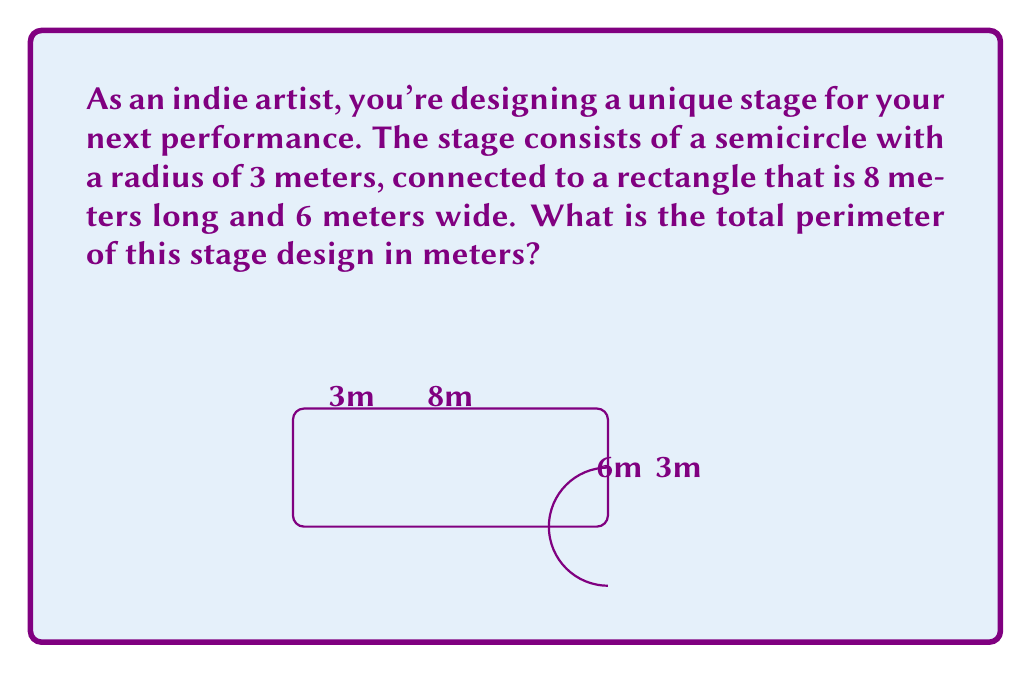Give your solution to this math problem. Let's break this down step-by-step:

1) First, let's identify the parts of the perimeter:
   - The straight edge of the semicircle
   - The curved part of the semicircle
   - Three sides of the rectangle (the fourth side is connected to the semicircle)

2) The straight edge of the semicircle is equal to its diameter:
   $$ \text{Diameter} = 2 \times \text{radius} = 2 \times 3 = 6 \text{ meters} $$

3) The curved part of the semicircle is half the circumference of a full circle:
   $$ \text{Curved part} = \frac{1}{2} \times 2\pi r = \pi r = \pi \times 3 = 3\pi \text{ meters} $$

4) For the rectangle, we need to add its length and two widths:
   $$ \text{Rectangle sides} = 8 + 6 + 6 = 20 \text{ meters} $$

5) Now, we can add all these parts together:
   $$ \text{Total perimeter} = 6 + 3\pi + 20 = 26 + 3\pi \text{ meters} $$

6) If we want to give a decimal approximation:
   $$ 26 + 3\pi \approx 26 + 9.42 = 35.42 \text{ meters} $$
Answer: $26 + 3\pi$ meters or approximately 35.42 meters 